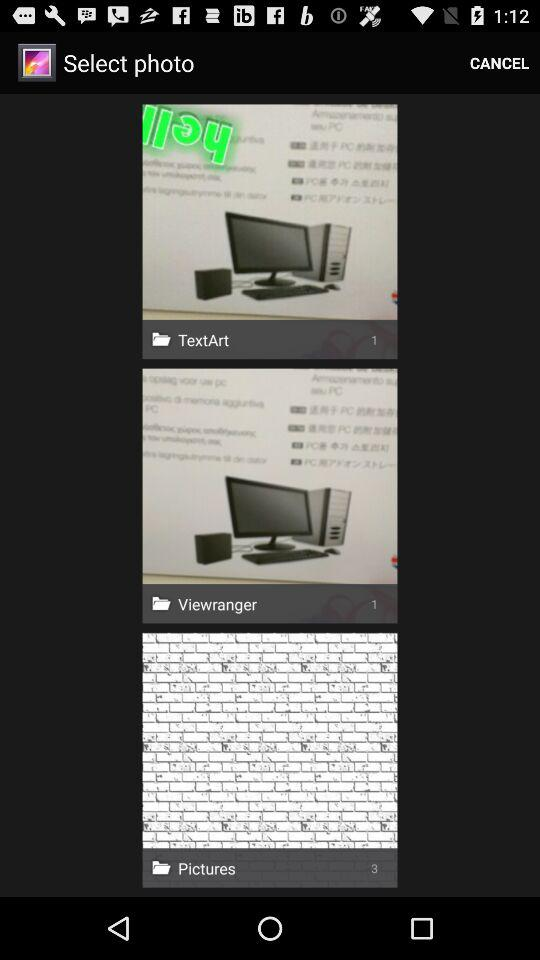In which folder are there 3 photos? The folder is "Pictures". 